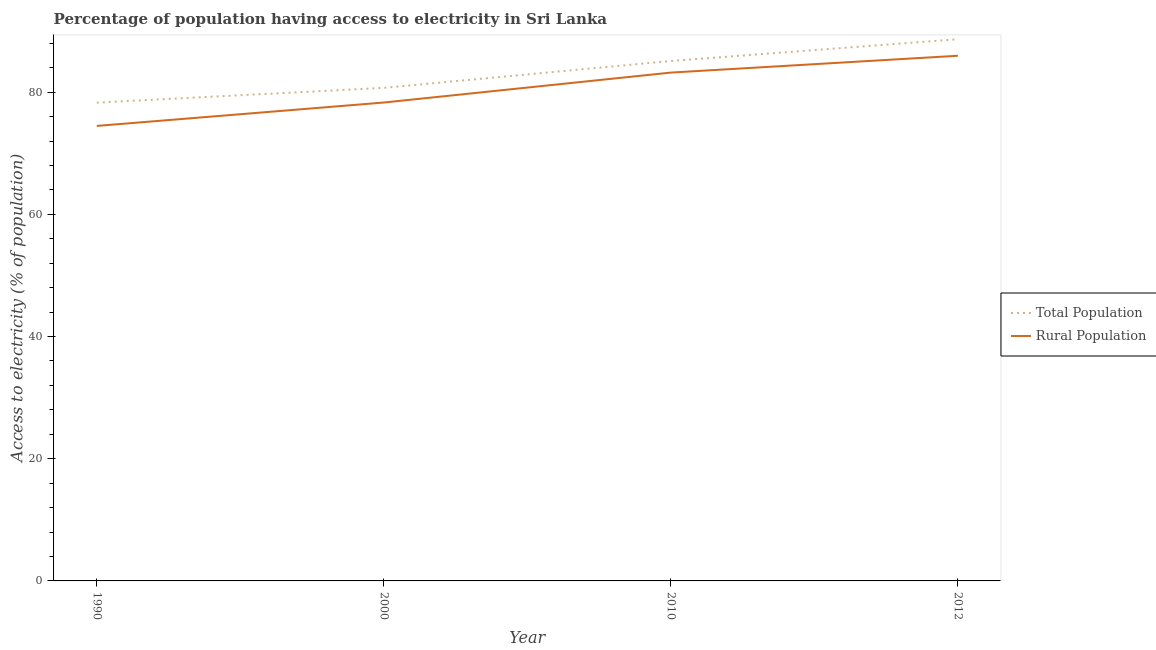Is the number of lines equal to the number of legend labels?
Make the answer very short. Yes. What is the percentage of rural population having access to electricity in 2010?
Your answer should be very brief. 83.2. Across all years, what is the maximum percentage of rural population having access to electricity?
Offer a very short reply. 85.95. Across all years, what is the minimum percentage of population having access to electricity?
Offer a terse response. 78.29. In which year was the percentage of population having access to electricity maximum?
Offer a terse response. 2012. What is the total percentage of population having access to electricity in the graph?
Provide a short and direct response. 332.75. What is the difference between the percentage of population having access to electricity in 2000 and that in 2012?
Your answer should be very brief. -7.96. What is the average percentage of rural population having access to electricity per year?
Give a very brief answer. 80.48. In the year 2010, what is the difference between the percentage of rural population having access to electricity and percentage of population having access to electricity?
Offer a terse response. -1.9. In how many years, is the percentage of population having access to electricity greater than 72 %?
Your answer should be very brief. 4. What is the ratio of the percentage of population having access to electricity in 2010 to that in 2012?
Provide a succinct answer. 0.96. Is the difference between the percentage of population having access to electricity in 2000 and 2010 greater than the difference between the percentage of rural population having access to electricity in 2000 and 2010?
Make the answer very short. Yes. What is the difference between the highest and the second highest percentage of rural population having access to electricity?
Provide a succinct answer. 2.75. What is the difference between the highest and the lowest percentage of rural population having access to electricity?
Your answer should be compact. 11.48. In how many years, is the percentage of rural population having access to electricity greater than the average percentage of rural population having access to electricity taken over all years?
Give a very brief answer. 2. Does the percentage of population having access to electricity monotonically increase over the years?
Your answer should be very brief. Yes. Is the percentage of rural population having access to electricity strictly less than the percentage of population having access to electricity over the years?
Ensure brevity in your answer.  Yes. What is the difference between two consecutive major ticks on the Y-axis?
Make the answer very short. 20. Does the graph contain any zero values?
Ensure brevity in your answer.  No. Where does the legend appear in the graph?
Your answer should be compact. Center right. How many legend labels are there?
Keep it short and to the point. 2. How are the legend labels stacked?
Keep it short and to the point. Vertical. What is the title of the graph?
Your answer should be compact. Percentage of population having access to electricity in Sri Lanka. What is the label or title of the X-axis?
Offer a very short reply. Year. What is the label or title of the Y-axis?
Offer a terse response. Access to electricity (% of population). What is the Access to electricity (% of population) of Total Population in 1990?
Offer a terse response. 78.29. What is the Access to electricity (% of population) in Rural Population in 1990?
Your response must be concise. 74.47. What is the Access to electricity (% of population) of Total Population in 2000?
Your answer should be very brief. 80.7. What is the Access to electricity (% of population) of Rural Population in 2000?
Ensure brevity in your answer.  78.3. What is the Access to electricity (% of population) in Total Population in 2010?
Ensure brevity in your answer.  85.1. What is the Access to electricity (% of population) of Rural Population in 2010?
Keep it short and to the point. 83.2. What is the Access to electricity (% of population) of Total Population in 2012?
Give a very brief answer. 88.66. What is the Access to electricity (% of population) in Rural Population in 2012?
Provide a short and direct response. 85.95. Across all years, what is the maximum Access to electricity (% of population) in Total Population?
Ensure brevity in your answer.  88.66. Across all years, what is the maximum Access to electricity (% of population) of Rural Population?
Provide a short and direct response. 85.95. Across all years, what is the minimum Access to electricity (% of population) in Total Population?
Give a very brief answer. 78.29. Across all years, what is the minimum Access to electricity (% of population) of Rural Population?
Give a very brief answer. 74.47. What is the total Access to electricity (% of population) of Total Population in the graph?
Ensure brevity in your answer.  332.75. What is the total Access to electricity (% of population) in Rural Population in the graph?
Provide a short and direct response. 321.92. What is the difference between the Access to electricity (% of population) in Total Population in 1990 and that in 2000?
Offer a very short reply. -2.41. What is the difference between the Access to electricity (% of population) of Rural Population in 1990 and that in 2000?
Ensure brevity in your answer.  -3.83. What is the difference between the Access to electricity (% of population) of Total Population in 1990 and that in 2010?
Offer a terse response. -6.81. What is the difference between the Access to electricity (% of population) of Rural Population in 1990 and that in 2010?
Your answer should be very brief. -8.73. What is the difference between the Access to electricity (% of population) in Total Population in 1990 and that in 2012?
Your response must be concise. -10.37. What is the difference between the Access to electricity (% of population) in Rural Population in 1990 and that in 2012?
Give a very brief answer. -11.48. What is the difference between the Access to electricity (% of population) in Total Population in 2000 and that in 2012?
Your response must be concise. -7.96. What is the difference between the Access to electricity (% of population) of Rural Population in 2000 and that in 2012?
Give a very brief answer. -7.65. What is the difference between the Access to electricity (% of population) of Total Population in 2010 and that in 2012?
Offer a very short reply. -3.56. What is the difference between the Access to electricity (% of population) of Rural Population in 2010 and that in 2012?
Make the answer very short. -2.75. What is the difference between the Access to electricity (% of population) in Total Population in 1990 and the Access to electricity (% of population) in Rural Population in 2000?
Offer a very short reply. -0.01. What is the difference between the Access to electricity (% of population) in Total Population in 1990 and the Access to electricity (% of population) in Rural Population in 2010?
Give a very brief answer. -4.91. What is the difference between the Access to electricity (% of population) in Total Population in 1990 and the Access to electricity (% of population) in Rural Population in 2012?
Your response must be concise. -7.67. What is the difference between the Access to electricity (% of population) in Total Population in 2000 and the Access to electricity (% of population) in Rural Population in 2012?
Offer a very short reply. -5.25. What is the difference between the Access to electricity (% of population) of Total Population in 2010 and the Access to electricity (% of population) of Rural Population in 2012?
Provide a short and direct response. -0.85. What is the average Access to electricity (% of population) in Total Population per year?
Provide a short and direct response. 83.19. What is the average Access to electricity (% of population) in Rural Population per year?
Keep it short and to the point. 80.48. In the year 1990, what is the difference between the Access to electricity (% of population) in Total Population and Access to electricity (% of population) in Rural Population?
Offer a very short reply. 3.82. In the year 2010, what is the difference between the Access to electricity (% of population) of Total Population and Access to electricity (% of population) of Rural Population?
Keep it short and to the point. 1.9. In the year 2012, what is the difference between the Access to electricity (% of population) in Total Population and Access to electricity (% of population) in Rural Population?
Make the answer very short. 2.71. What is the ratio of the Access to electricity (% of population) in Total Population in 1990 to that in 2000?
Provide a short and direct response. 0.97. What is the ratio of the Access to electricity (% of population) of Rural Population in 1990 to that in 2000?
Your answer should be very brief. 0.95. What is the ratio of the Access to electricity (% of population) of Total Population in 1990 to that in 2010?
Your answer should be very brief. 0.92. What is the ratio of the Access to electricity (% of population) of Rural Population in 1990 to that in 2010?
Provide a succinct answer. 0.9. What is the ratio of the Access to electricity (% of population) in Total Population in 1990 to that in 2012?
Make the answer very short. 0.88. What is the ratio of the Access to electricity (% of population) of Rural Population in 1990 to that in 2012?
Provide a short and direct response. 0.87. What is the ratio of the Access to electricity (% of population) in Total Population in 2000 to that in 2010?
Make the answer very short. 0.95. What is the ratio of the Access to electricity (% of population) of Rural Population in 2000 to that in 2010?
Offer a terse response. 0.94. What is the ratio of the Access to electricity (% of population) in Total Population in 2000 to that in 2012?
Keep it short and to the point. 0.91. What is the ratio of the Access to electricity (% of population) of Rural Population in 2000 to that in 2012?
Your response must be concise. 0.91. What is the ratio of the Access to electricity (% of population) of Total Population in 2010 to that in 2012?
Your answer should be compact. 0.96. What is the ratio of the Access to electricity (% of population) of Rural Population in 2010 to that in 2012?
Offer a terse response. 0.97. What is the difference between the highest and the second highest Access to electricity (% of population) of Total Population?
Keep it short and to the point. 3.56. What is the difference between the highest and the second highest Access to electricity (% of population) of Rural Population?
Make the answer very short. 2.75. What is the difference between the highest and the lowest Access to electricity (% of population) in Total Population?
Your answer should be very brief. 10.37. What is the difference between the highest and the lowest Access to electricity (% of population) in Rural Population?
Your answer should be very brief. 11.48. 